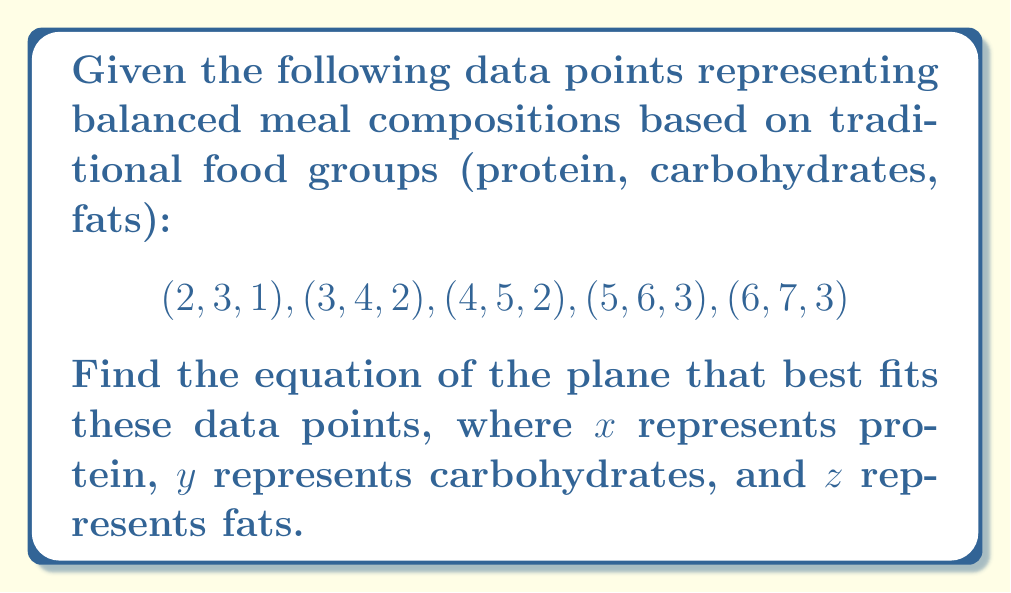Can you solve this math problem? To find the equation of the plane that best fits the given data points, we'll use the method of least squares. The general equation of a plane is:

$$z = ax + by + c$$

1) First, we need to set up the system of equations:

   $$\begin{cases}
   2a + 3b + c = 1 \\
   3a + 4b + c = 2 \\
   4a + 5b + c = 2 \\
   5a + 6b + c = 3 \\
   6a + 7b + c = 3
   \end{cases}$$

2) We can represent this system in matrix form:

   $$\begin{bmatrix}
   2 & 3 & 1 \\
   3 & 4 & 1 \\
   4 & 5 & 1 \\
   5 & 6 & 1 \\
   6 & 7 & 1
   \end{bmatrix}
   \begin{bmatrix}
   a \\ b \\ c
   \end{bmatrix} =
   \begin{bmatrix}
   1 \\ 2 \\ 2 \\ 3 \\ 3
   \end{bmatrix}$$

3) Let's call the matrix on the left A, the vector of unknowns X, and the vector on the right B. We need to solve:

   $$A^T AX = A^T B$$

4) Calculating $A^T A$:

   $$A^T A = \begin{bmatrix}
   90 & 110 & 20 \\
   110 & 135 & 25 \\
   20 & 25 & 5
   \end{bmatrix}$$

5) Calculating $A^T B$:

   $$A^T B = \begin{bmatrix}
   40 \\ 49 \\ 11
   \end{bmatrix}$$

6) Now we need to solve the system:

   $$\begin{bmatrix}
   90 & 110 & 20 \\
   110 & 135 & 25 \\
   20 & 25 & 5
   \end{bmatrix}
   \begin{bmatrix}
   a \\ b \\ c
   \end{bmatrix} =
   \begin{bmatrix}
   40 \\ 49 \\ 11
   \end{bmatrix}$$

7) Solving this system (using Gaussian elimination or matrix inversion) gives:

   $$a \approx 0.4, b \approx 0.1, c \approx 0.2$$

8) Therefore, the equation of the plane that best fits the data is:

   $$z = 0.4x + 0.1y + 0.2$$

This equation represents the balanced meal composition based on traditional food groups, where $x$ is protein, $y$ is carbohydrates, and $z$ is fats.
Answer: $$z = 0.4x + 0.1y + 0.2$$ 